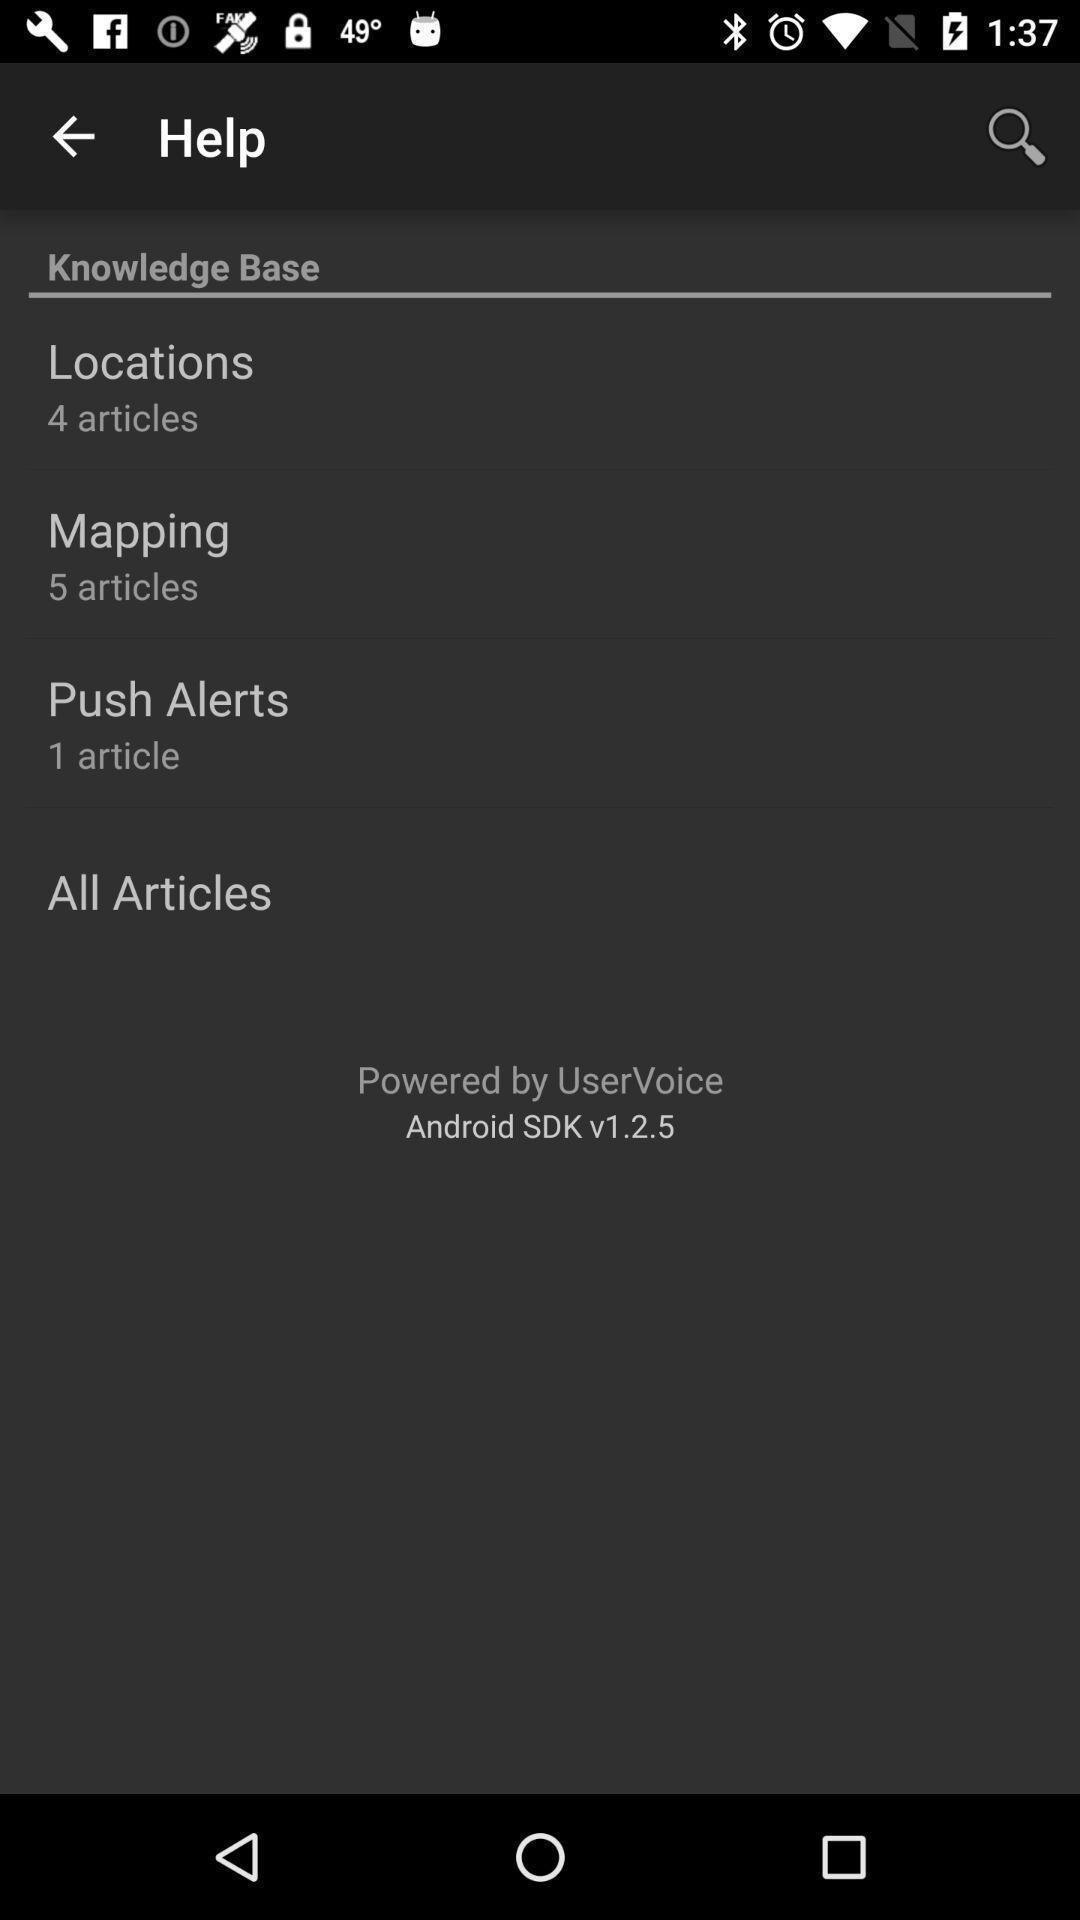Describe the content in this image. Screen displaying multiple features in help page. 